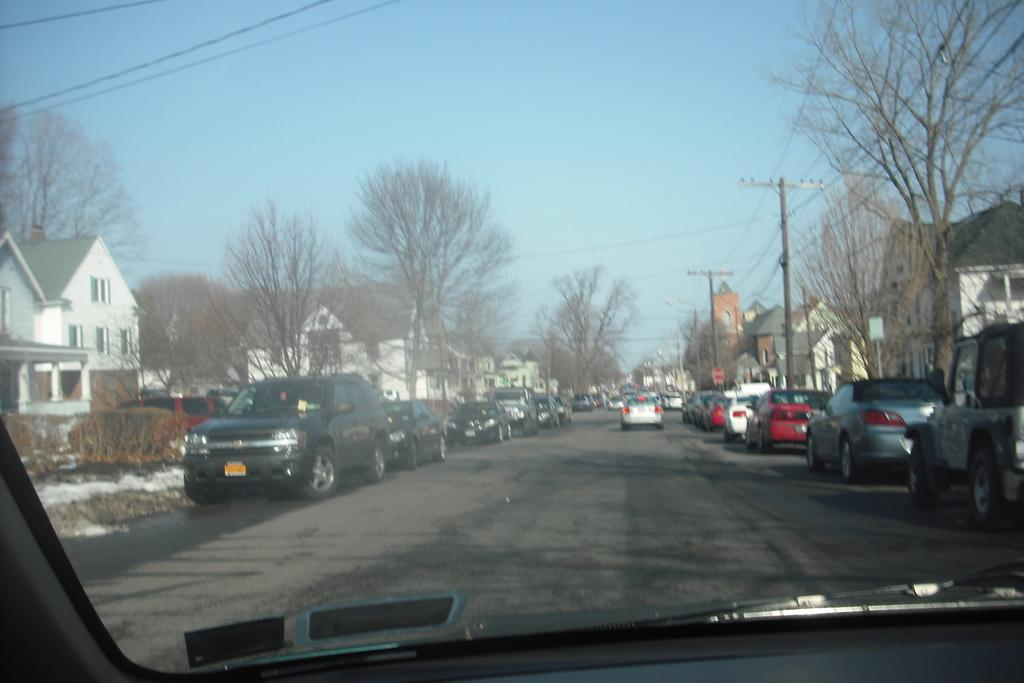What types of vehicles can be seen in the image? There are motor vehicles in the image. What structures are present in the image that are related to electricity? Electric poles and electric cables are visible in the image. What type of natural vegetation is present in the image? There are trees in the image. What type of man-made structures can be seen in the image? Buildings are present in the image. What part of the natural environment is visible in the image? The sky is visible in the image. What type of animal can be seen designing a building in the image? There are no animals present in the image, and no animals are shown designing a building. What type of lumber is used to construct the buildings in the image? The buildings in the image are made of materials other than lumber, as there is no mention of lumber in the provided facts. 